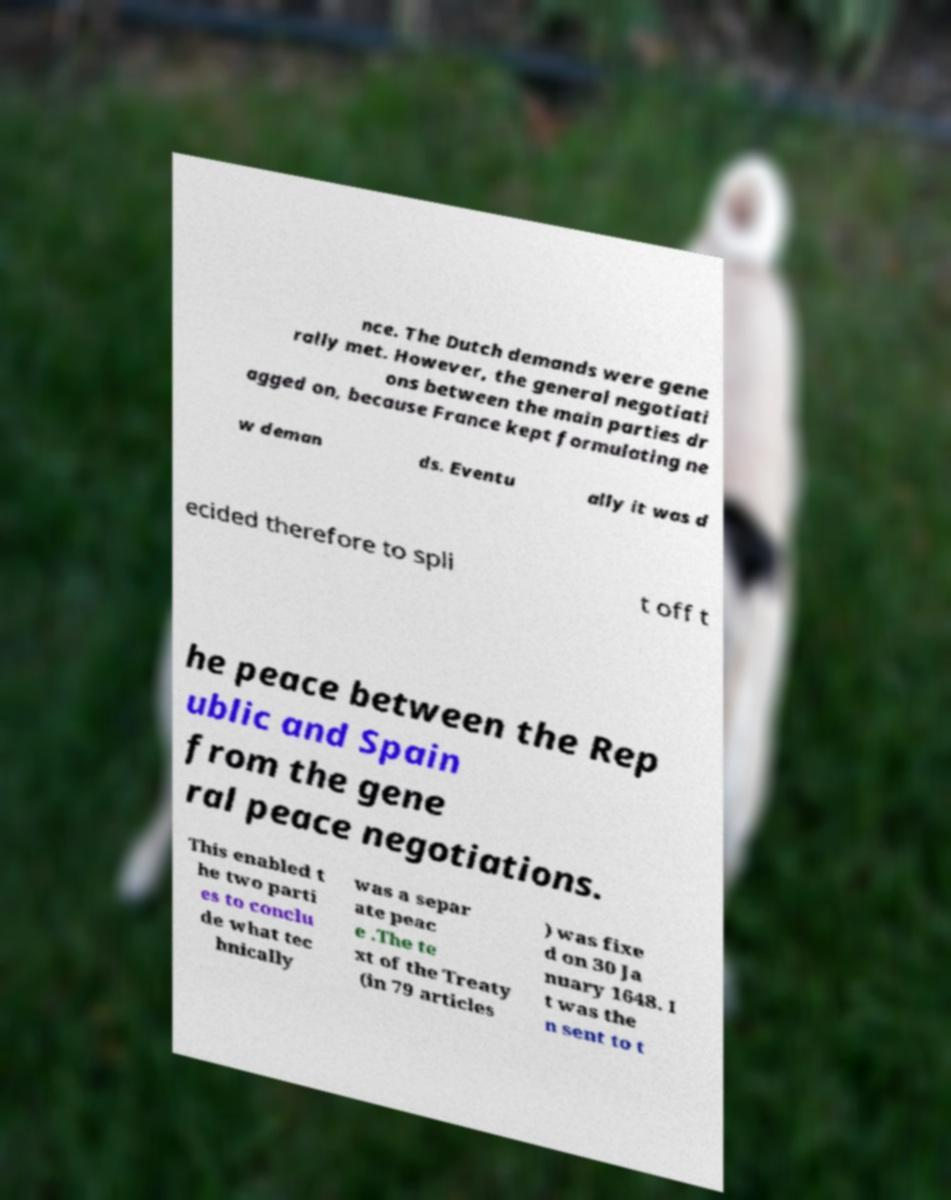For documentation purposes, I need the text within this image transcribed. Could you provide that? nce. The Dutch demands were gene rally met. However, the general negotiati ons between the main parties dr agged on, because France kept formulating ne w deman ds. Eventu ally it was d ecided therefore to spli t off t he peace between the Rep ublic and Spain from the gene ral peace negotiations. This enabled t he two parti es to conclu de what tec hnically was a separ ate peac e .The te xt of the Treaty (in 79 articles ) was fixe d on 30 Ja nuary 1648. I t was the n sent to t 